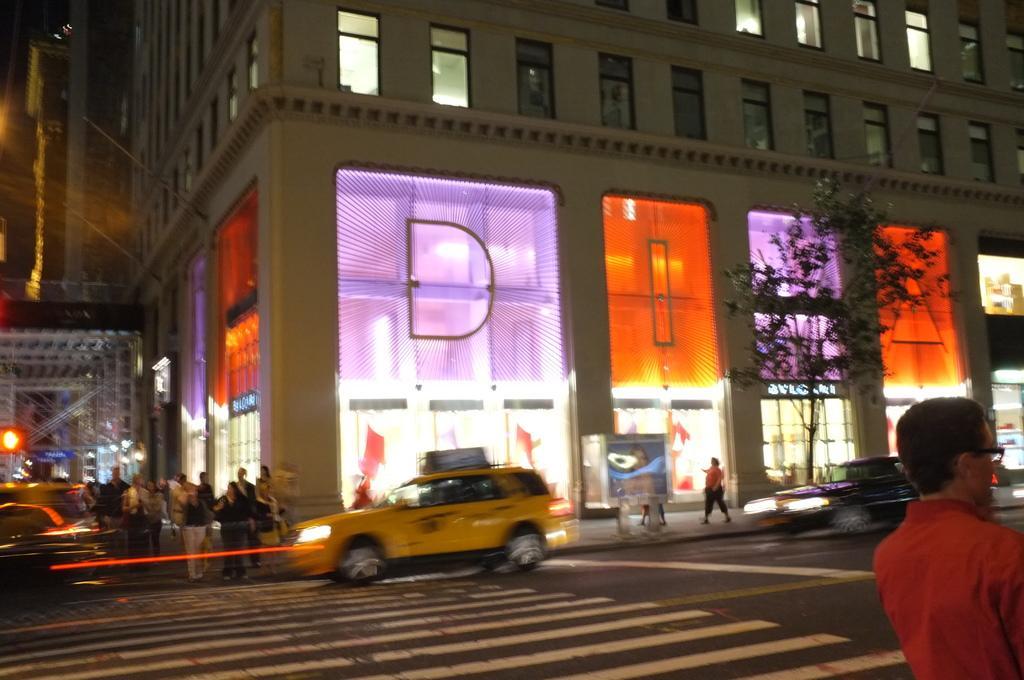Can you describe this image briefly? In this image I can see, on the right side there is a man. He wore spectacles, shirt. In the middle a yellow color car is moving on the road and there is a very big building. On the right side there is a tree, on the left side few people are walking on this road. 